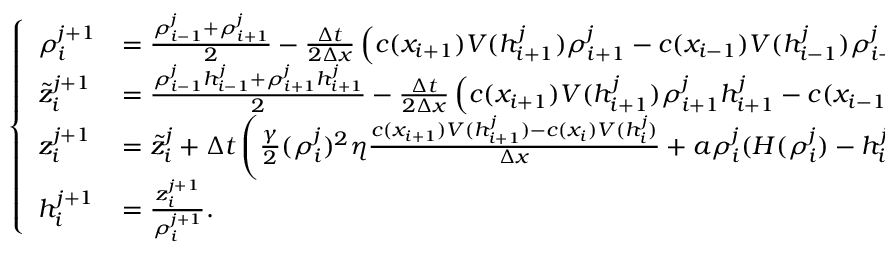<formula> <loc_0><loc_0><loc_500><loc_500>\begin{array} { r } { \left \{ \begin{array} { l l } { \rho _ { i } ^ { j + 1 } } & { = \frac { \rho _ { i - 1 } ^ { j } + \rho _ { i + 1 } ^ { j } } { 2 } - \frac { \Delta t } { 2 \Delta x } \left ( c ( x _ { i + 1 } ) V ( h _ { i + 1 } ^ { j } ) \rho _ { i + 1 } ^ { j } - c ( x _ { i - 1 } ) V ( h _ { i - 1 } ^ { j } ) \rho _ { i - 1 } ^ { j } \right ) , } \\ { \tilde { z } _ { i } ^ { j + 1 } } & { = \frac { \rho _ { i - 1 } ^ { j } h _ { i - 1 } ^ { j } + \rho _ { i + 1 } ^ { j } h _ { i + 1 } ^ { j } } { 2 } - \frac { \Delta t } { 2 \Delta x } \left ( c ( x _ { i + 1 } ) V ( h _ { i + 1 } ^ { j } ) \rho _ { i + 1 } ^ { j } h _ { i + 1 } ^ { j } - c ( x _ { i - 1 } ) V ( h _ { i - 1 } ^ { j } ) \rho _ { i - 1 } ^ { j } h _ { i - 1 } ^ { j } \right ) , } \\ { z _ { i } ^ { j + 1 } } & { = \tilde { z } _ { i } ^ { j } + \Delta t \left ( \frac { \gamma } { 2 } ( \rho _ { i } ^ { j } ) ^ { 2 } \eta \frac { c ( x _ { i + 1 } ) V ( h _ { i + 1 } ^ { j } ) - c ( x _ { i } ) V ( h _ { i } ^ { j } ) } { \Delta x } + a \rho _ { i } ^ { j } ( H ( \rho _ { i } ^ { j } ) - h _ { i } ^ { j } ) \right ) , } \\ { h _ { i } ^ { j + 1 } } & { = \frac { z _ { i } ^ { j + 1 } } { \rho _ { i } ^ { j + 1 } } . } \end{array} } \end{array}</formula> 